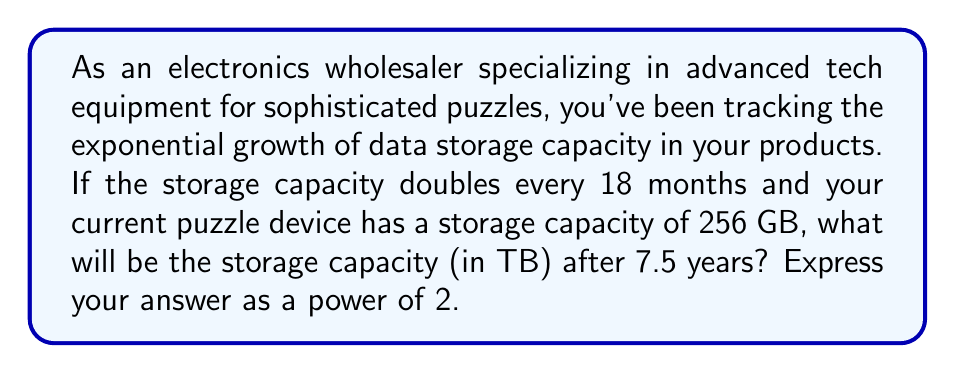Show me your answer to this math problem. Let's approach this step-by-step:

1) First, we need to determine how many 18-month periods are in 7.5 years:
   
   $$ \text{Number of periods} = \frac{7.5 \text{ years} \times 12 \text{ months/year}}{18 \text{ months/period}} = 5 \text{ periods} $$

2) Now, we know that the capacity doubles every period. This means we're dealing with exponential growth with a base of 2. After 5 periods, we can express this as:

   $$ \text{New capacity} = 256 \text{ GB} \times 2^5 $$

3) Let's calculate this:
   
   $$ 256 \times 2^5 = 256 \times 32 = 8192 \text{ GB} $$

4) We need to convert this to TB. Knowing that 1 TB = 1024 GB:

   $$ 8192 \text{ GB} = \frac{8192}{1024} \text{ TB} = 8 \text{ TB} $$

5) Finally, we need to express this as a power of 2:

   $$ 8 \text{ TB} = 2^3 \text{ TB} $$

Thus, after 7.5 years, the storage capacity will be $2^3$ TB.
Answer: $2^3$ TB 